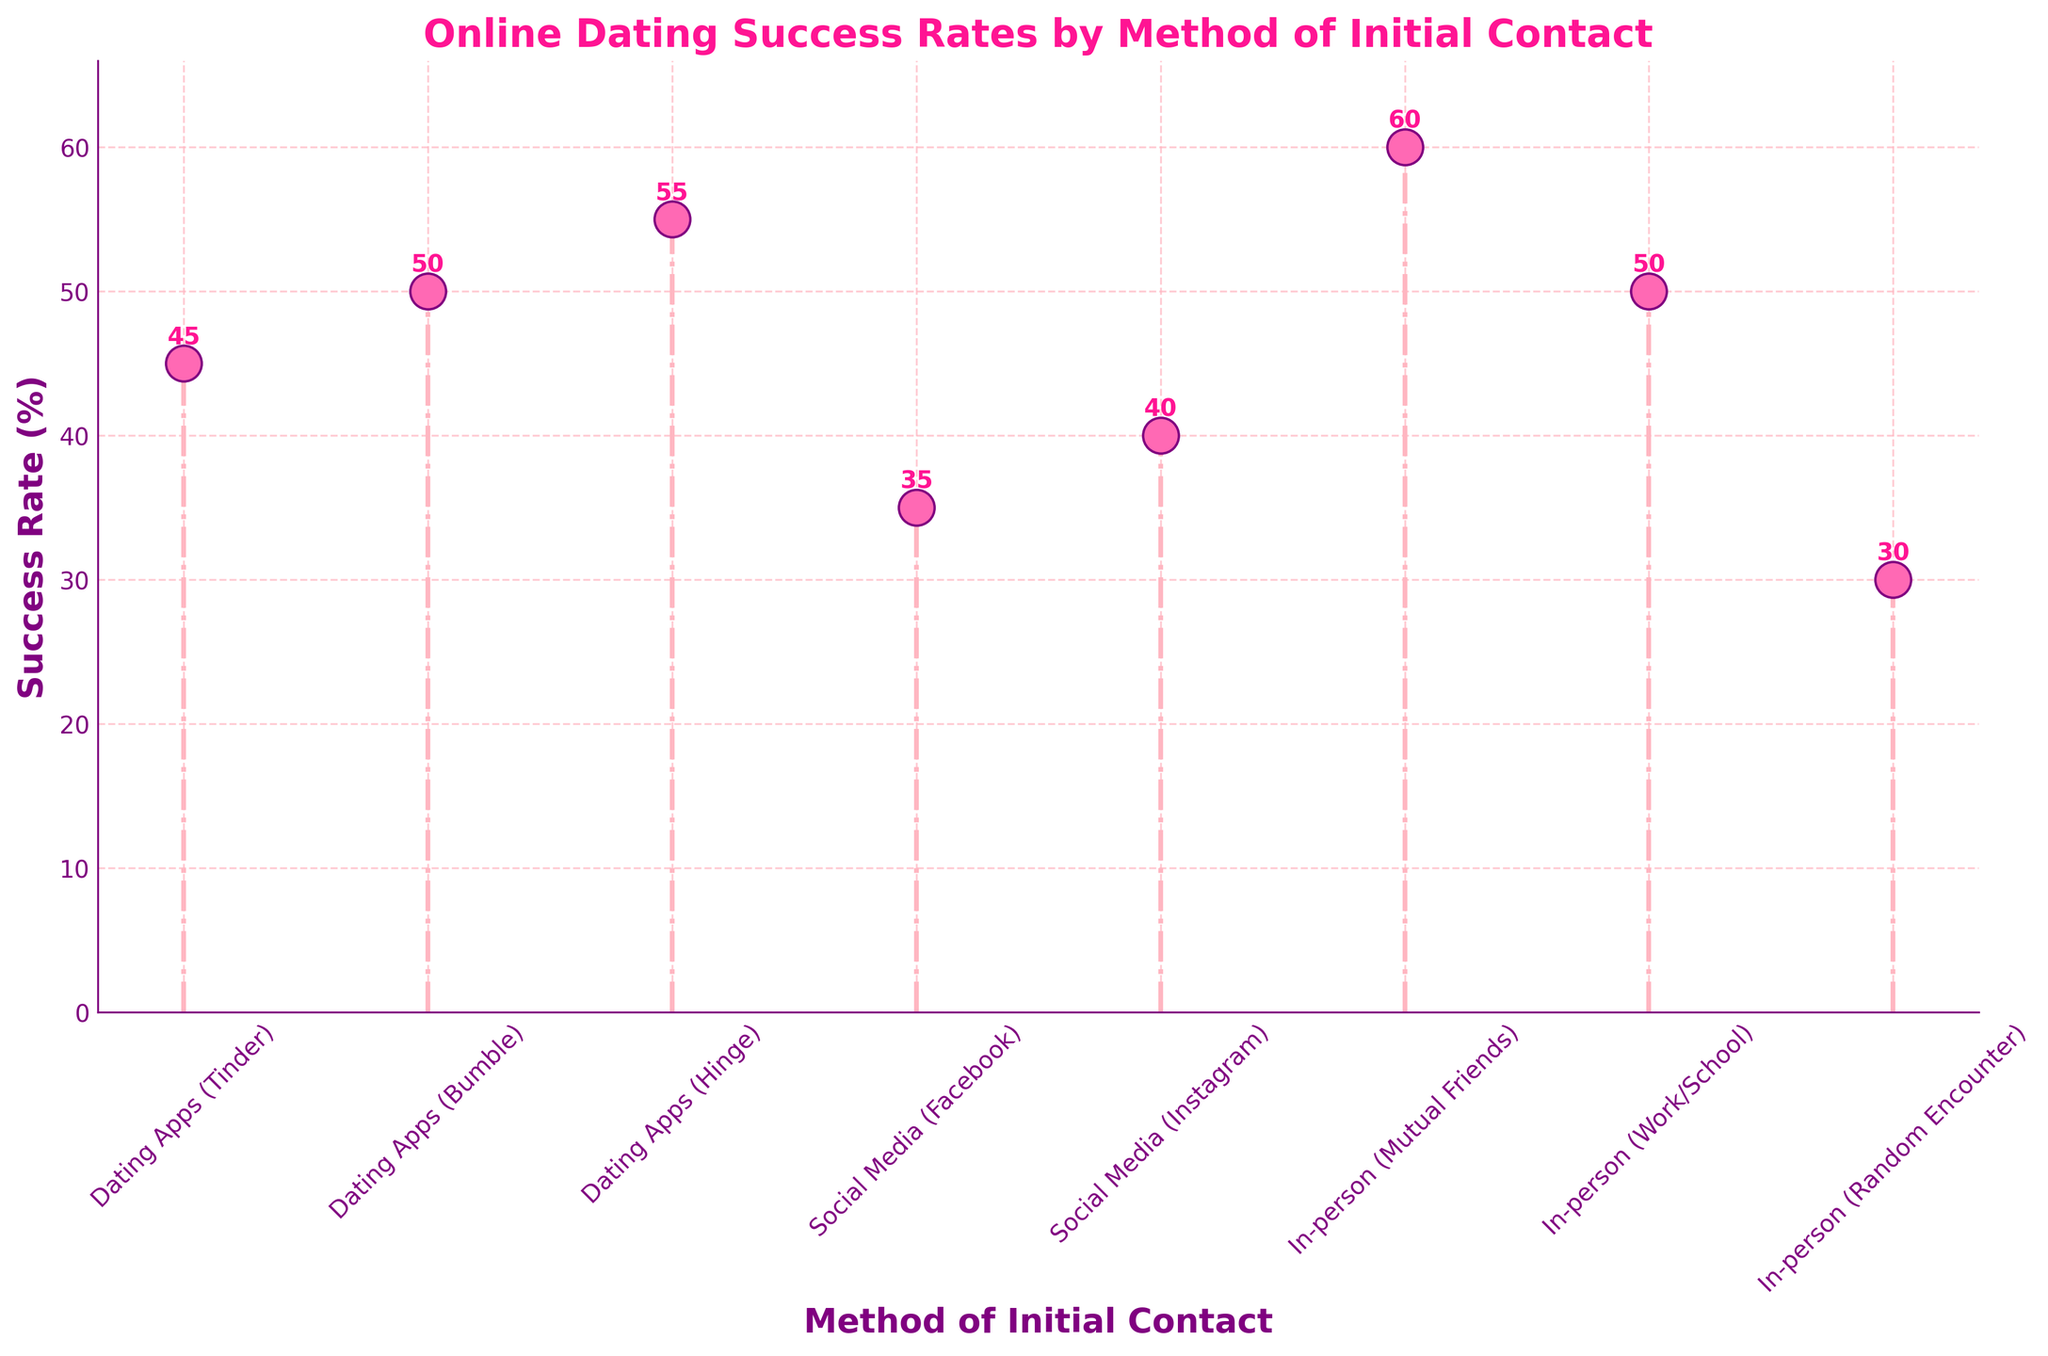What's the title of the figure? The title of the figure is displayed at the top of the plot and is usually written in larger, bold font. In this case, it reads "Online Dating Success Rates by Method of Initial Contact."
Answer: Online Dating Success Rates by Method of Initial Contact What's the highest success rate for any method? By examining the y-axis labels and the top of the stem lines, you can identify the highest success rate. The tallest stem corresponds to "In-person (Mutual Friends)" with a success rate of 60%.
Answer: 60% Which method has the lowest success rate? By looking for the shortest stem on the plot, we can see "In-person (Random Encounter)" has the shortest stem length, indicating it has the lowest success rate at 30%.
Answer: In-person (Random Encounter) Compare the success rates of Dating Apps (Bumble) and Social Media (Instagram). Which one is higher and by how much? First, locate the positions of "Dating Apps (Bumble)" and "Social Media (Instagram)" on the x-axis. The stem for Bumble reaches 50%, while Instagram reaches 40%. Comparing these, Bumble is higher by 50% - 40% = 10%.
Answer: Dating Apps (Bumble) is higher by 10% What is the average success rate of all "In-person" methods? To find the average, sum the success rates of all "In-person" methods (60%, 50%, 30%) and divide by the number of these methods. (60 + 50 + 30) / 3 = 140 / 3 ≈ 46.67%.
Answer: 46.67% How many methods have a success rate of 50% or more? By counting the stems that reach the 50% mark or go beyond it, we identify these methods: "Dating Apps (Bumble)", "Dating Apps (Hinge)", "In-person (Mutual Friends)", and "In-person (Work/School)." This totals to 4 methods.
Answer: 4 Which "Dating Apps" have the highest and lowest success rates, and what are these rates? Locate all the "Dating Apps" methods: Tinder, Bumble, and Hinge. Tinder has the lowest success rate at 45%, while Hinge has the highest at 55%.
Answer: Hinge (55%), Tinder (45%) What is the difference in success rate between the highest "Social Media" method and the lowest "In-person" method? First, identify the highest success rate under "Social Media" which is "Instagram" at 40%. Then, find the lowest success rate under "In-person" which is a "Random Encounter" at 30%. The difference is 40% - 30% = 10%.
Answer: 10% If you sum the success rates of "Dating Apps (Hinge)" and "In-person (Work/School)," what is the result? Success rates for "Hinge" and "Work/School" are 55% and 50%, respectively. Summing these gives 55 + 50 = 105%.
Answer: 105% Which color are the stem lines and what is their line style? The stem lines have a light pink color and a dash-dot (.-) line style as noticed from the visual cues provided in the plot.
Answer: Light pink, dash-dot 